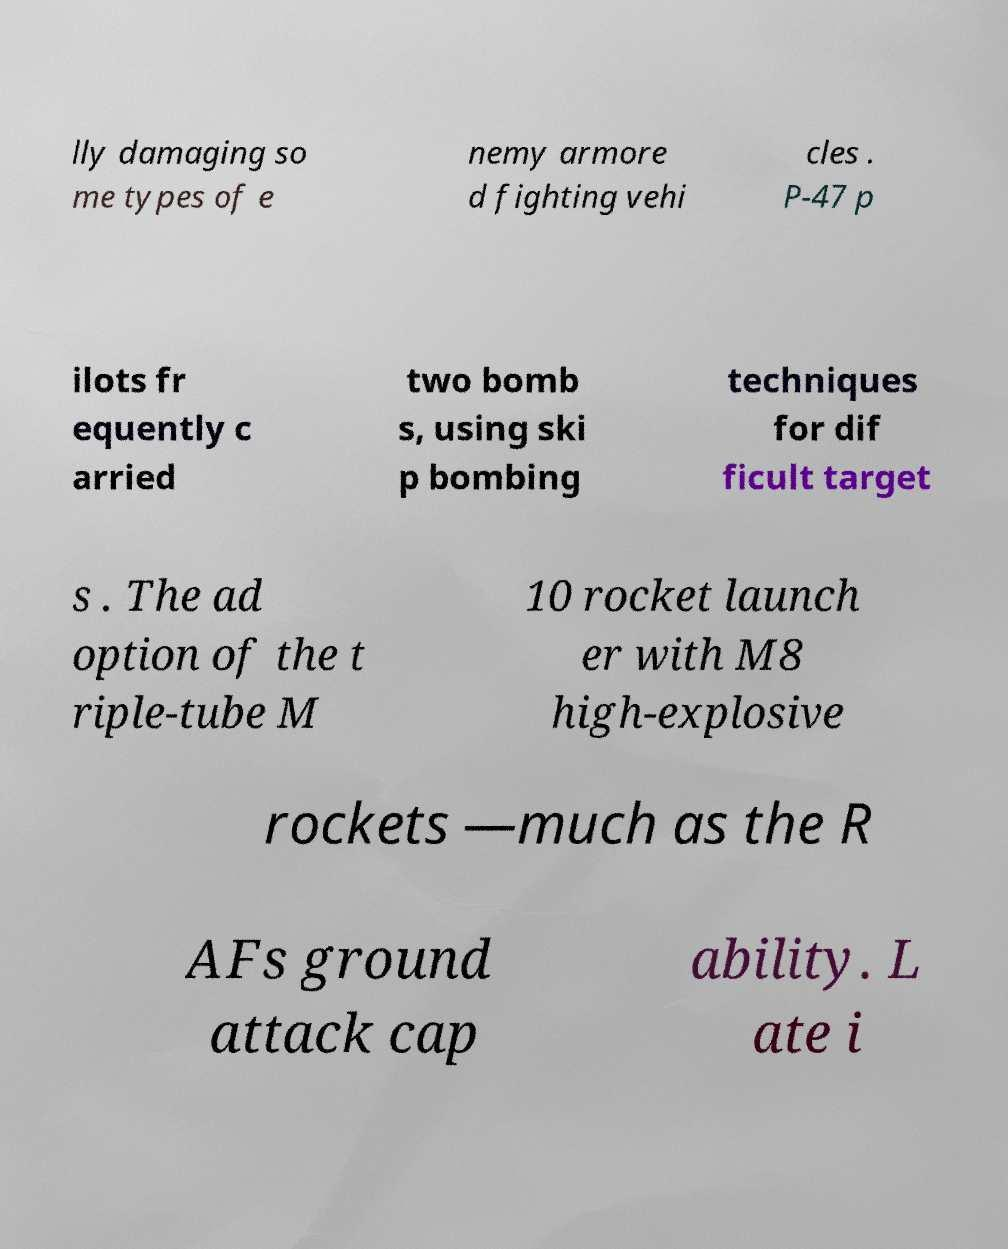What messages or text are displayed in this image? I need them in a readable, typed format. lly damaging so me types of e nemy armore d fighting vehi cles . P-47 p ilots fr equently c arried two bomb s, using ski p bombing techniques for dif ficult target s . The ad option of the t riple-tube M 10 rocket launch er with M8 high-explosive rockets —much as the R AFs ground attack cap ability. L ate i 